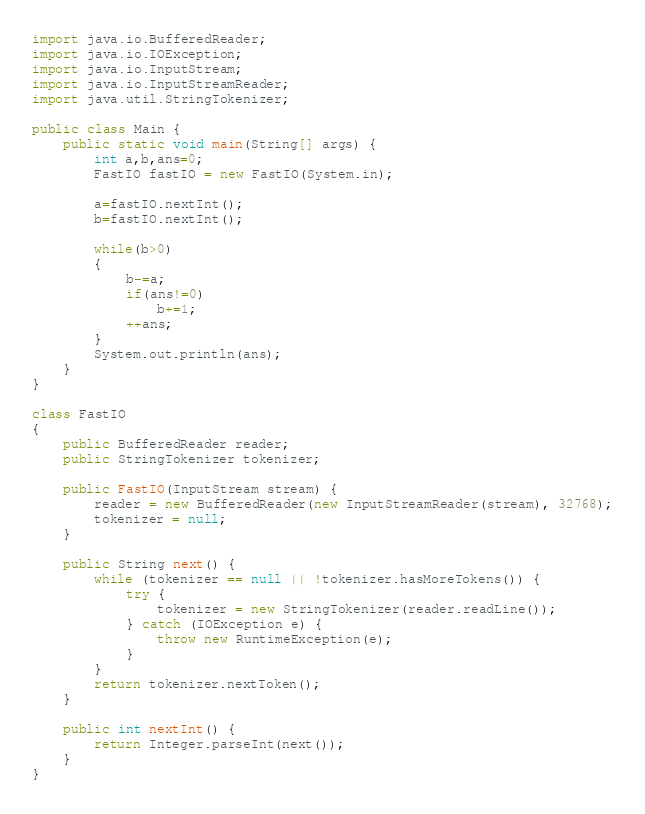Convert code to text. <code><loc_0><loc_0><loc_500><loc_500><_Java_>import java.io.BufferedReader;
import java.io.IOException;
import java.io.InputStream;
import java.io.InputStreamReader;
import java.util.StringTokenizer;

public class Main {
    public static void main(String[] args) {
        int a,b,ans=0;
        FastIO fastIO = new FastIO(System.in);

        a=fastIO.nextInt();
        b=fastIO.nextInt();

        while(b>0)
        {
            b-=a;
            if(ans!=0)
                b+=1;
            ++ans;
        }
        System.out.println(ans);
    }
}

class FastIO
{
    public BufferedReader reader;
    public StringTokenizer tokenizer;

    public FastIO(InputStream stream) {
        reader = new BufferedReader(new InputStreamReader(stream), 32768);
        tokenizer = null;
    }

    public String next() {
        while (tokenizer == null || !tokenizer.hasMoreTokens()) {
            try {
                tokenizer = new StringTokenizer(reader.readLine());
            } catch (IOException e) {
                throw new RuntimeException(e);
            }
        }
        return tokenizer.nextToken();
    }

    public int nextInt() {
        return Integer.parseInt(next());
    }
}
</code> 